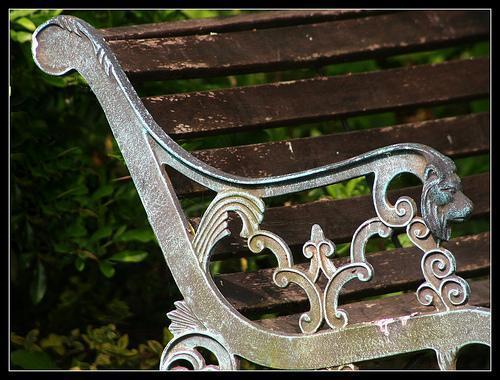How many benches are in the photo?
Give a very brief answer. 1. 